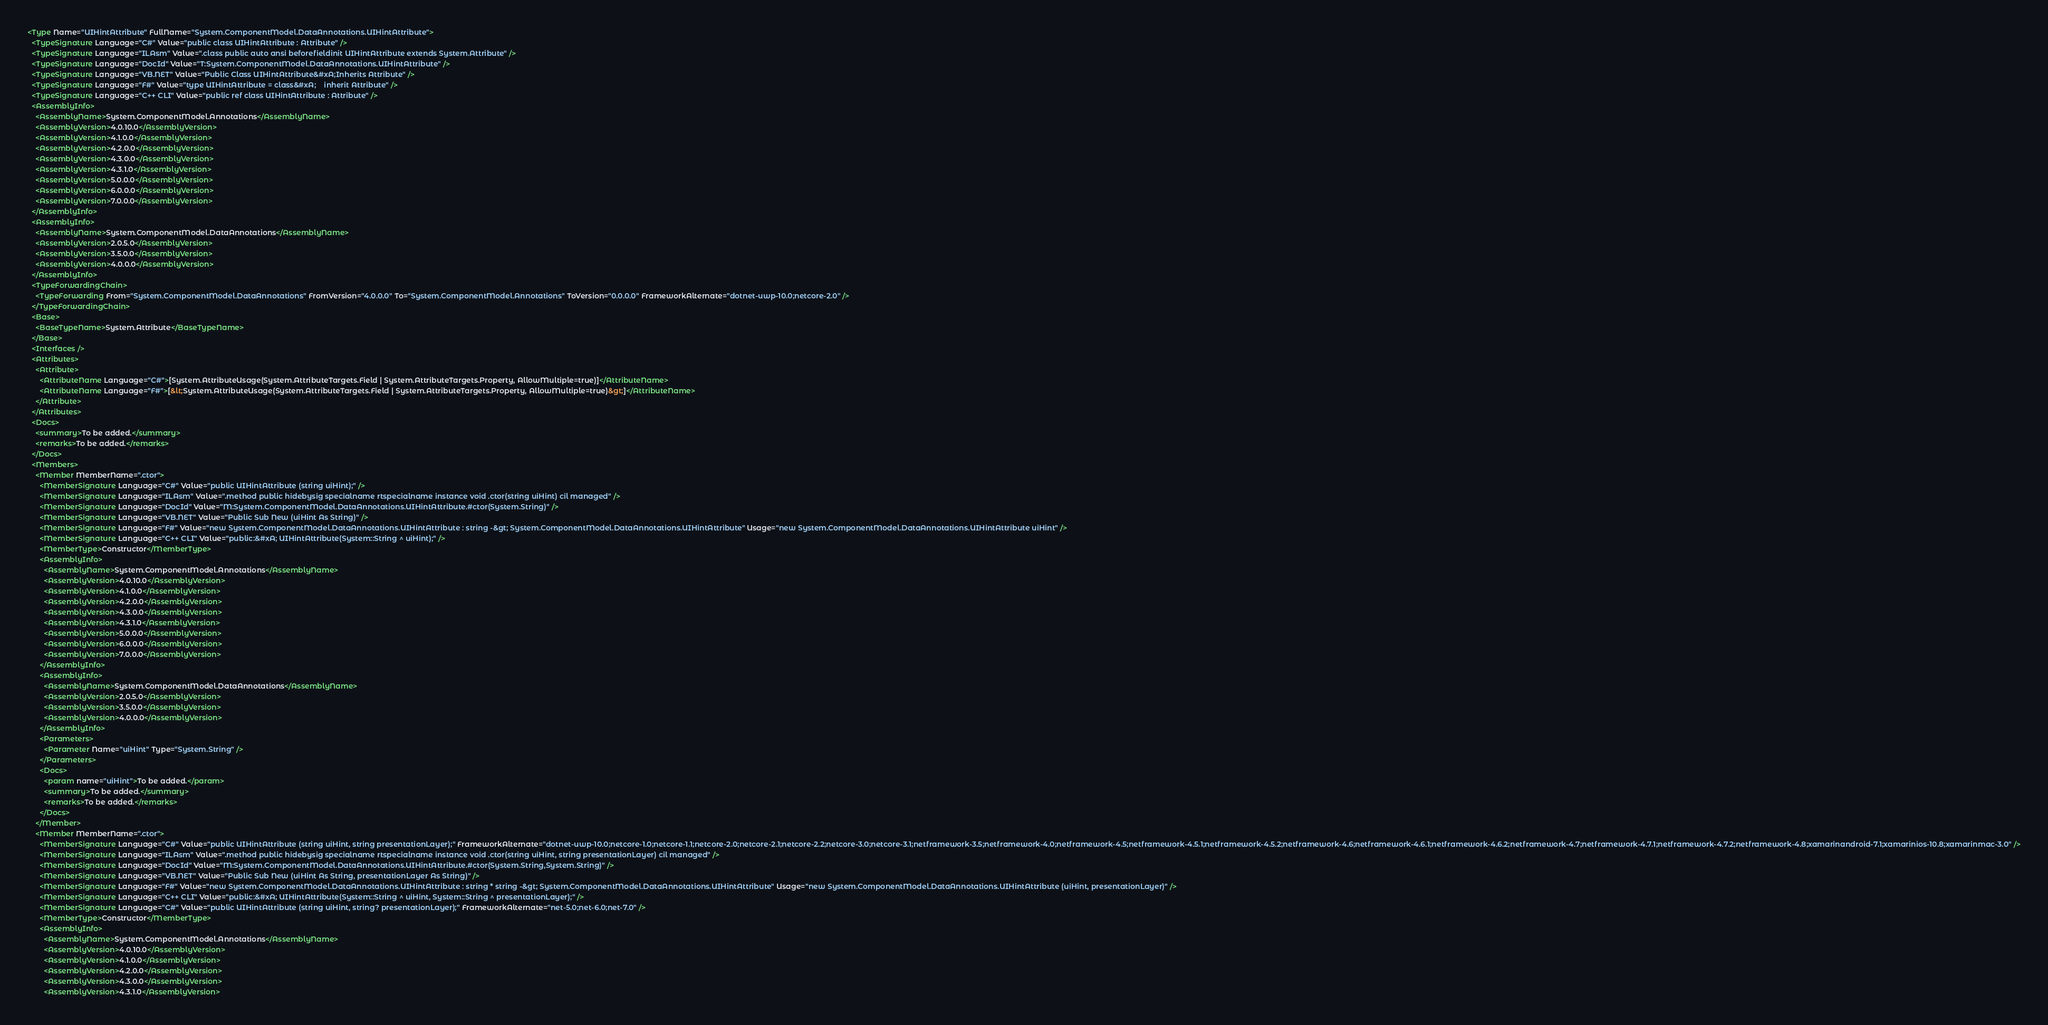Convert code to text. <code><loc_0><loc_0><loc_500><loc_500><_XML_><Type Name="UIHintAttribute" FullName="System.ComponentModel.DataAnnotations.UIHintAttribute">
  <TypeSignature Language="C#" Value="public class UIHintAttribute : Attribute" />
  <TypeSignature Language="ILAsm" Value=".class public auto ansi beforefieldinit UIHintAttribute extends System.Attribute" />
  <TypeSignature Language="DocId" Value="T:System.ComponentModel.DataAnnotations.UIHintAttribute" />
  <TypeSignature Language="VB.NET" Value="Public Class UIHintAttribute&#xA;Inherits Attribute" />
  <TypeSignature Language="F#" Value="type UIHintAttribute = class&#xA;    inherit Attribute" />
  <TypeSignature Language="C++ CLI" Value="public ref class UIHintAttribute : Attribute" />
  <AssemblyInfo>
    <AssemblyName>System.ComponentModel.Annotations</AssemblyName>
    <AssemblyVersion>4.0.10.0</AssemblyVersion>
    <AssemblyVersion>4.1.0.0</AssemblyVersion>
    <AssemblyVersion>4.2.0.0</AssemblyVersion>
    <AssemblyVersion>4.3.0.0</AssemblyVersion>
    <AssemblyVersion>4.3.1.0</AssemblyVersion>
    <AssemblyVersion>5.0.0.0</AssemblyVersion>
    <AssemblyVersion>6.0.0.0</AssemblyVersion>
    <AssemblyVersion>7.0.0.0</AssemblyVersion>
  </AssemblyInfo>
  <AssemblyInfo>
    <AssemblyName>System.ComponentModel.DataAnnotations</AssemblyName>
    <AssemblyVersion>2.0.5.0</AssemblyVersion>
    <AssemblyVersion>3.5.0.0</AssemblyVersion>
    <AssemblyVersion>4.0.0.0</AssemblyVersion>
  </AssemblyInfo>
  <TypeForwardingChain>
    <TypeForwarding From="System.ComponentModel.DataAnnotations" FromVersion="4.0.0.0" To="System.ComponentModel.Annotations" ToVersion="0.0.0.0" FrameworkAlternate="dotnet-uwp-10.0;netcore-2.0" />
  </TypeForwardingChain>
  <Base>
    <BaseTypeName>System.Attribute</BaseTypeName>
  </Base>
  <Interfaces />
  <Attributes>
    <Attribute>
      <AttributeName Language="C#">[System.AttributeUsage(System.AttributeTargets.Field | System.AttributeTargets.Property, AllowMultiple=true)]</AttributeName>
      <AttributeName Language="F#">[&lt;System.AttributeUsage(System.AttributeTargets.Field | System.AttributeTargets.Property, AllowMultiple=true)&gt;]</AttributeName>
    </Attribute>
  </Attributes>
  <Docs>
    <summary>To be added.</summary>
    <remarks>To be added.</remarks>
  </Docs>
  <Members>
    <Member MemberName=".ctor">
      <MemberSignature Language="C#" Value="public UIHintAttribute (string uiHint);" />
      <MemberSignature Language="ILAsm" Value=".method public hidebysig specialname rtspecialname instance void .ctor(string uiHint) cil managed" />
      <MemberSignature Language="DocId" Value="M:System.ComponentModel.DataAnnotations.UIHintAttribute.#ctor(System.String)" />
      <MemberSignature Language="VB.NET" Value="Public Sub New (uiHint As String)" />
      <MemberSignature Language="F#" Value="new System.ComponentModel.DataAnnotations.UIHintAttribute : string -&gt; System.ComponentModel.DataAnnotations.UIHintAttribute" Usage="new System.ComponentModel.DataAnnotations.UIHintAttribute uiHint" />
      <MemberSignature Language="C++ CLI" Value="public:&#xA; UIHintAttribute(System::String ^ uiHint);" />
      <MemberType>Constructor</MemberType>
      <AssemblyInfo>
        <AssemblyName>System.ComponentModel.Annotations</AssemblyName>
        <AssemblyVersion>4.0.10.0</AssemblyVersion>
        <AssemblyVersion>4.1.0.0</AssemblyVersion>
        <AssemblyVersion>4.2.0.0</AssemblyVersion>
        <AssemblyVersion>4.3.0.0</AssemblyVersion>
        <AssemblyVersion>4.3.1.0</AssemblyVersion>
        <AssemblyVersion>5.0.0.0</AssemblyVersion>
        <AssemblyVersion>6.0.0.0</AssemblyVersion>
        <AssemblyVersion>7.0.0.0</AssemblyVersion>
      </AssemblyInfo>
      <AssemblyInfo>
        <AssemblyName>System.ComponentModel.DataAnnotations</AssemblyName>
        <AssemblyVersion>2.0.5.0</AssemblyVersion>
        <AssemblyVersion>3.5.0.0</AssemblyVersion>
        <AssemblyVersion>4.0.0.0</AssemblyVersion>
      </AssemblyInfo>
      <Parameters>
        <Parameter Name="uiHint" Type="System.String" />
      </Parameters>
      <Docs>
        <param name="uiHint">To be added.</param>
        <summary>To be added.</summary>
        <remarks>To be added.</remarks>
      </Docs>
    </Member>
    <Member MemberName=".ctor">
      <MemberSignature Language="C#" Value="public UIHintAttribute (string uiHint, string presentationLayer);" FrameworkAlternate="dotnet-uwp-10.0;netcore-1.0;netcore-1.1;netcore-2.0;netcore-2.1;netcore-2.2;netcore-3.0;netcore-3.1;netframework-3.5;netframework-4.0;netframework-4.5;netframework-4.5.1;netframework-4.5.2;netframework-4.6;netframework-4.6.1;netframework-4.6.2;netframework-4.7;netframework-4.7.1;netframework-4.7.2;netframework-4.8;xamarinandroid-7.1;xamarinios-10.8;xamarinmac-3.0" />
      <MemberSignature Language="ILAsm" Value=".method public hidebysig specialname rtspecialname instance void .ctor(string uiHint, string presentationLayer) cil managed" />
      <MemberSignature Language="DocId" Value="M:System.ComponentModel.DataAnnotations.UIHintAttribute.#ctor(System.String,System.String)" />
      <MemberSignature Language="VB.NET" Value="Public Sub New (uiHint As String, presentationLayer As String)" />
      <MemberSignature Language="F#" Value="new System.ComponentModel.DataAnnotations.UIHintAttribute : string * string -&gt; System.ComponentModel.DataAnnotations.UIHintAttribute" Usage="new System.ComponentModel.DataAnnotations.UIHintAttribute (uiHint, presentationLayer)" />
      <MemberSignature Language="C++ CLI" Value="public:&#xA; UIHintAttribute(System::String ^ uiHint, System::String ^ presentationLayer);" />
      <MemberSignature Language="C#" Value="public UIHintAttribute (string uiHint, string? presentationLayer);" FrameworkAlternate="net-5.0;net-6.0;net-7.0" />
      <MemberType>Constructor</MemberType>
      <AssemblyInfo>
        <AssemblyName>System.ComponentModel.Annotations</AssemblyName>
        <AssemblyVersion>4.0.10.0</AssemblyVersion>
        <AssemblyVersion>4.1.0.0</AssemblyVersion>
        <AssemblyVersion>4.2.0.0</AssemblyVersion>
        <AssemblyVersion>4.3.0.0</AssemblyVersion>
        <AssemblyVersion>4.3.1.0</AssemblyVersion></code> 